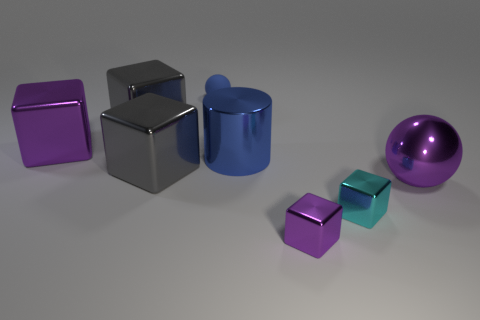Is there any other thing that has the same material as the tiny sphere?
Your response must be concise. No. There is a large purple metal object left of the big purple metal ball; what shape is it?
Make the answer very short. Cube. How many large metallic cubes are there?
Ensure brevity in your answer.  3. What color is the big ball that is the same material as the big purple block?
Keep it short and to the point. Purple. How many small things are spheres or shiny objects?
Provide a short and direct response. 3. There is a big purple block; how many purple blocks are right of it?
Ensure brevity in your answer.  1. What is the color of the other big thing that is the same shape as the matte thing?
Ensure brevity in your answer.  Purple. What number of rubber objects are either tiny blue blocks or blue cylinders?
Provide a succinct answer. 0. There is a big block that is to the left of the gray metallic cube that is behind the large cylinder; is there a big gray object behind it?
Your response must be concise. Yes. The matte object has what color?
Provide a short and direct response. Blue. 